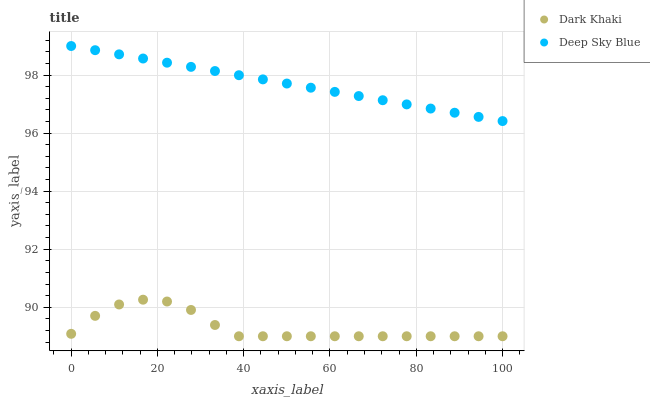Does Dark Khaki have the minimum area under the curve?
Answer yes or no. Yes. Does Deep Sky Blue have the maximum area under the curve?
Answer yes or no. Yes. Does Deep Sky Blue have the minimum area under the curve?
Answer yes or no. No. Is Deep Sky Blue the smoothest?
Answer yes or no. Yes. Is Dark Khaki the roughest?
Answer yes or no. Yes. Is Deep Sky Blue the roughest?
Answer yes or no. No. Does Dark Khaki have the lowest value?
Answer yes or no. Yes. Does Deep Sky Blue have the lowest value?
Answer yes or no. No. Does Deep Sky Blue have the highest value?
Answer yes or no. Yes. Is Dark Khaki less than Deep Sky Blue?
Answer yes or no. Yes. Is Deep Sky Blue greater than Dark Khaki?
Answer yes or no. Yes. Does Dark Khaki intersect Deep Sky Blue?
Answer yes or no. No. 